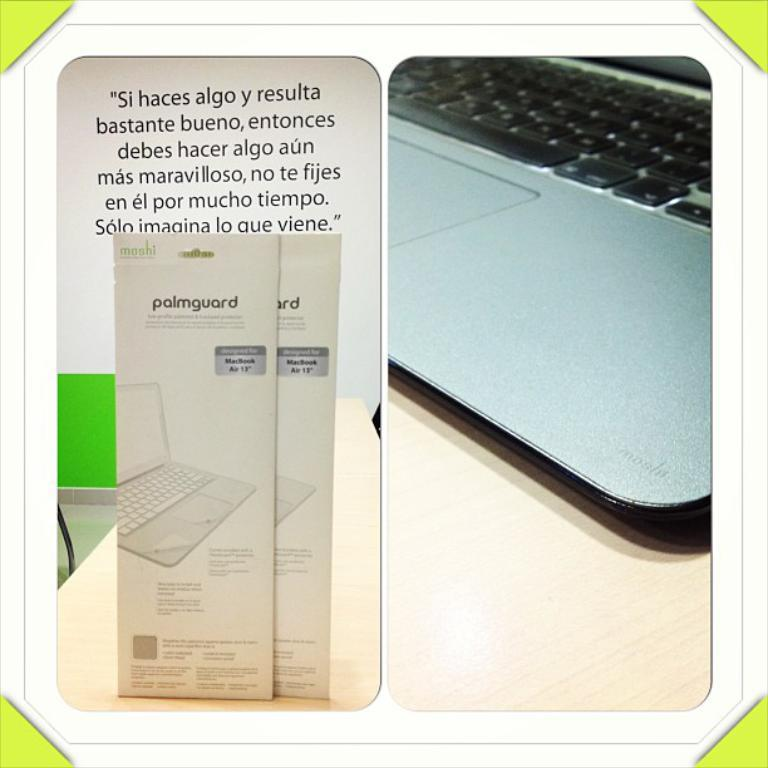Provide a one-sentence caption for the provided image. Two Palmguard products for the MacBook Air are on a desk. 